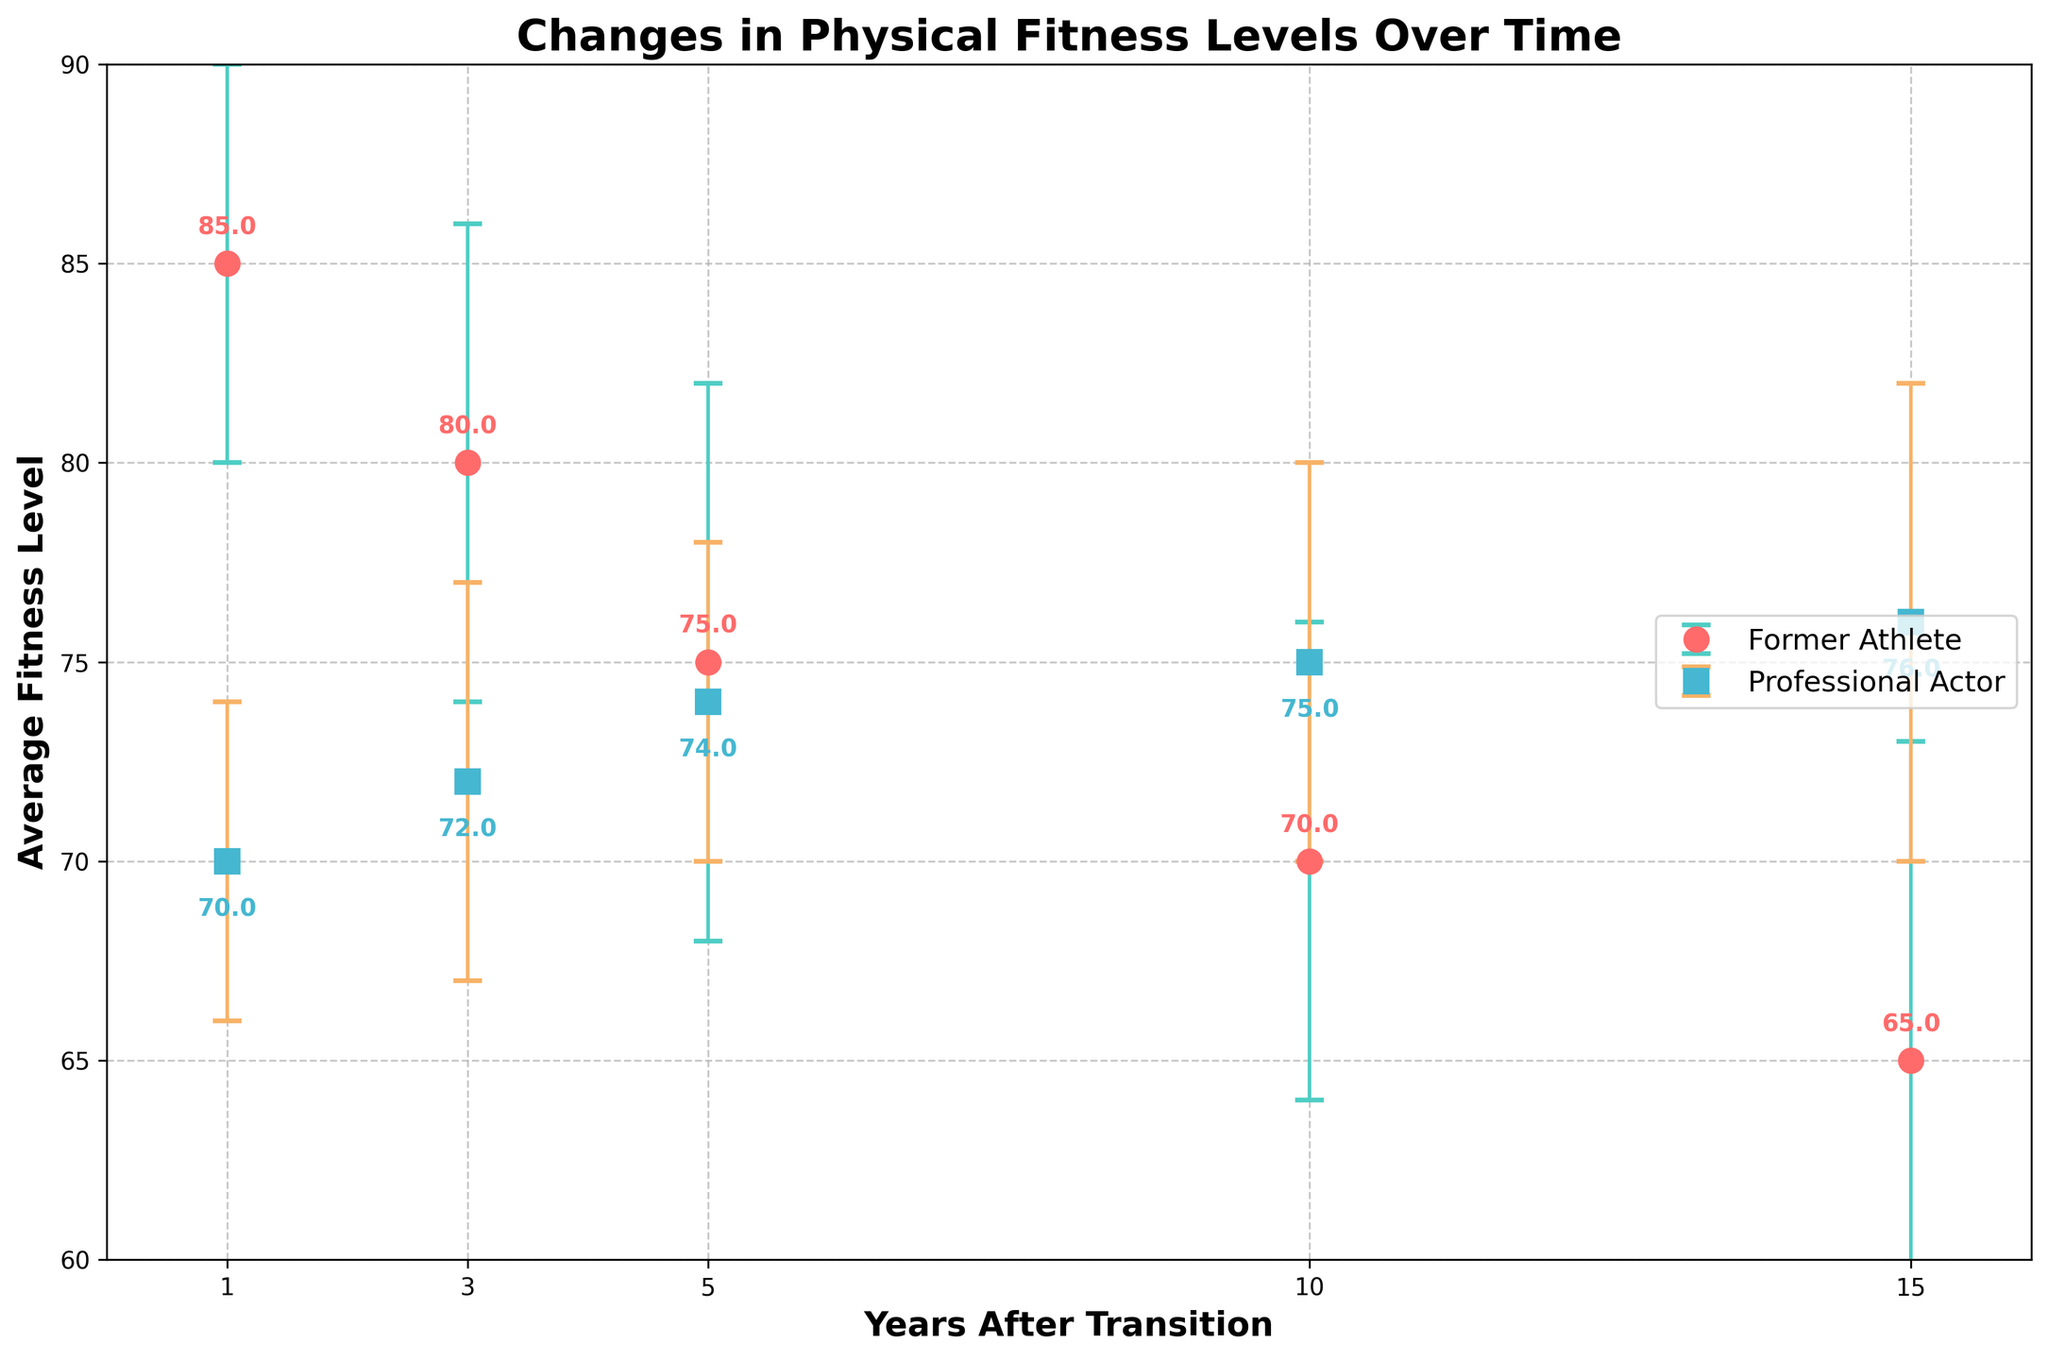what's the title of the plot? The title is usually displayed at the top of the plot. Here, it reads "Changes in Physical Fitness Levels Over Time."
Answer: Changes in Physical Fitness Levels Over Time how many years after transition does the plot cover? By looking at the x-axis labels, we can see the plot covers 1, 3, 5, 10, and 15 years after transition.
Answer: 5 years which group had the highest average fitness level 1 year after transition? The plot shows two points for 1 year after transition, one for 'Former Athlete' at 85 and one for 'Professional Actor' at 70. The highest is 'Former Athlete' at 85.
Answer: Former Athlete at 85 what is the trend in average fitness level for former athletes over 15 years? Starting from 85 at 1 year and decreasing over the years through 80, 75, 70, and finally reaching 65 at 15 years, the trend shows a continuous decline.
Answer: declining how do the fitness levels of former athletes compare to professional actors 10 years after transition? At the 10-year mark, former athletes have a fitness level of 70, while professional actors have a fitness level of 75. Professional actors are higher by 5 points.
Answer: professional actors higher by 5 what can be inferred from the standard deviation error bars about the variability in fitness levels in both groups? Error bars for former athletes increase from 5 to 8, indicating rising variability, while for professional actors, it remains relatively stable around 4-6, showing less variability.
Answer: Former Athletes show increasing variability, Professional Actors show stable variability compare the average fitness levels 5 years after the transition for both groups. According to the plot, 5 years after the transition, former athletes have an average fitness level of 75, while professional actors have 74. Former athletes are slightly higher by 1 point.
Answer: former athletes higher by 1 what might explain the crossing point of fitness levels between former athletes and professional actors? Former athletes start with higher fitness levels but decline over time, whereas professional actors show a slight increase, leading to a crossing point around the 10-year mark. Trends indicate differing adaptation processes.
Answer: differing adaptation processes what is the difference in average fitness levels between former athletes and professional actors 15 years after transition? At the 15-year mark, former athletes' average fitness is 65, while professional actors' is 76. The difference is 76 - 65 = 11.
Answer: 11 which group shows a marked improvement in fitness level over time? Observing the plot, professional actors initially have a lower fitness level of 70 but steadily increase to 76 over the period while former athletes decline.
Answer: professional actors 